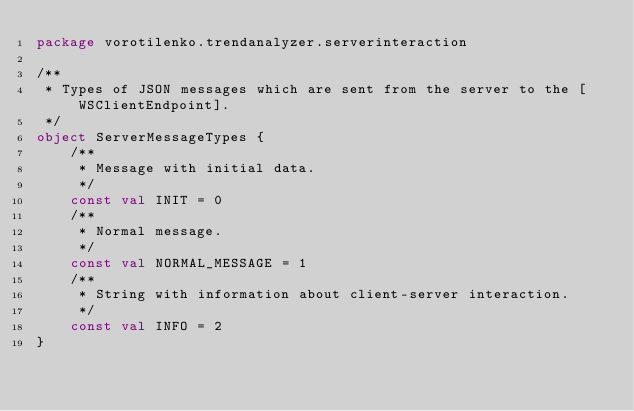Convert code to text. <code><loc_0><loc_0><loc_500><loc_500><_Kotlin_>package vorotilenko.trendanalyzer.serverinteraction

/**
 * Types of JSON messages which are sent from the server to the [WSClientEndpoint].
 */
object ServerMessageTypes {
    /**
     * Message with initial data.
     */
    const val INIT = 0
    /**
     * Normal message.
     */
    const val NORMAL_MESSAGE = 1
    /**
     * String with information about client-server interaction.
     */
    const val INFO = 2
}</code> 